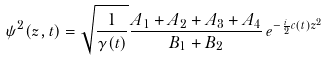Convert formula to latex. <formula><loc_0><loc_0><loc_500><loc_500>\psi ^ { 2 } ( z , t ) = \sqrt { \frac { 1 } { \gamma ( t ) } } \frac { A _ { 1 } + A _ { 2 } + A _ { 3 } + A _ { 4 } } { B _ { 1 } + B _ { 2 } } \, e ^ { - \frac { i } { 2 } c ( t ) z ^ { 2 } }</formula> 